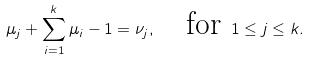<formula> <loc_0><loc_0><loc_500><loc_500>\mu _ { j } + \sum _ { i = 1 } ^ { k } \mu _ { i } - 1 = \nu _ { j } , \quad \text {for } 1 \leq j \leq k .</formula> 